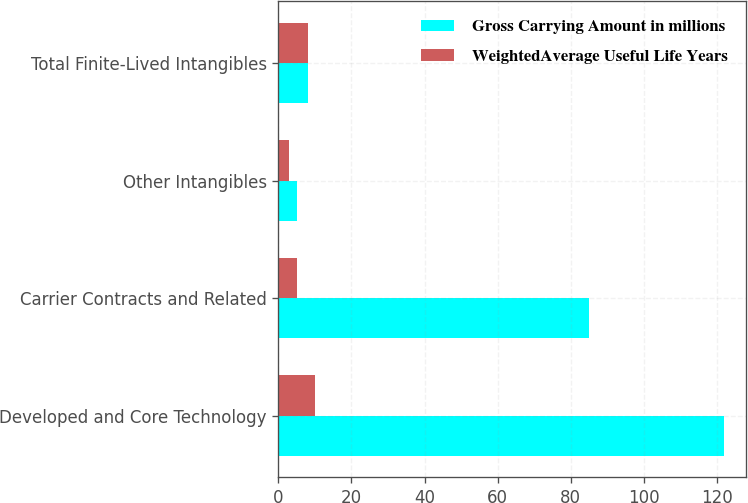Convert chart to OTSL. <chart><loc_0><loc_0><loc_500><loc_500><stacked_bar_chart><ecel><fcel>Developed and Core Technology<fcel>Carrier Contracts and Related<fcel>Other Intangibles<fcel>Total Finite-Lived Intangibles<nl><fcel>Gross Carrying Amount in millions<fcel>122<fcel>85<fcel>5<fcel>8<nl><fcel>WeightedAverage Useful Life Years<fcel>10<fcel>5<fcel>3<fcel>8<nl></chart> 